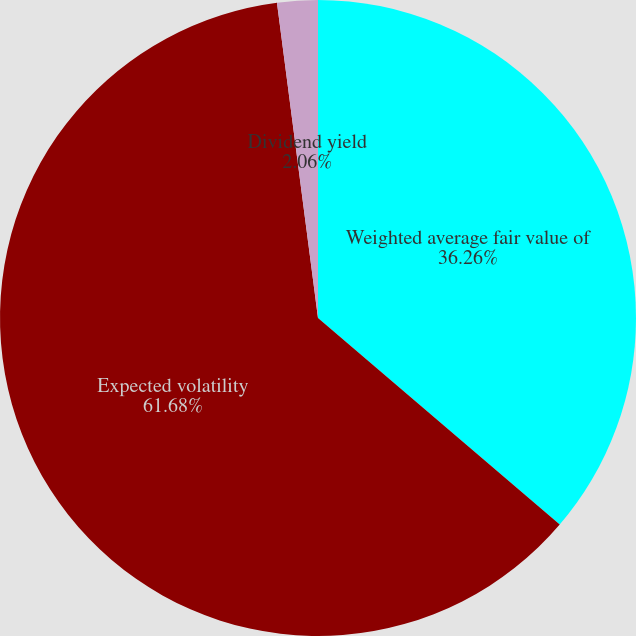Convert chart to OTSL. <chart><loc_0><loc_0><loc_500><loc_500><pie_chart><fcel>Weighted average fair value of<fcel>Expected volatility<fcel>Dividend yield<nl><fcel>36.26%<fcel>61.69%<fcel>2.06%<nl></chart> 